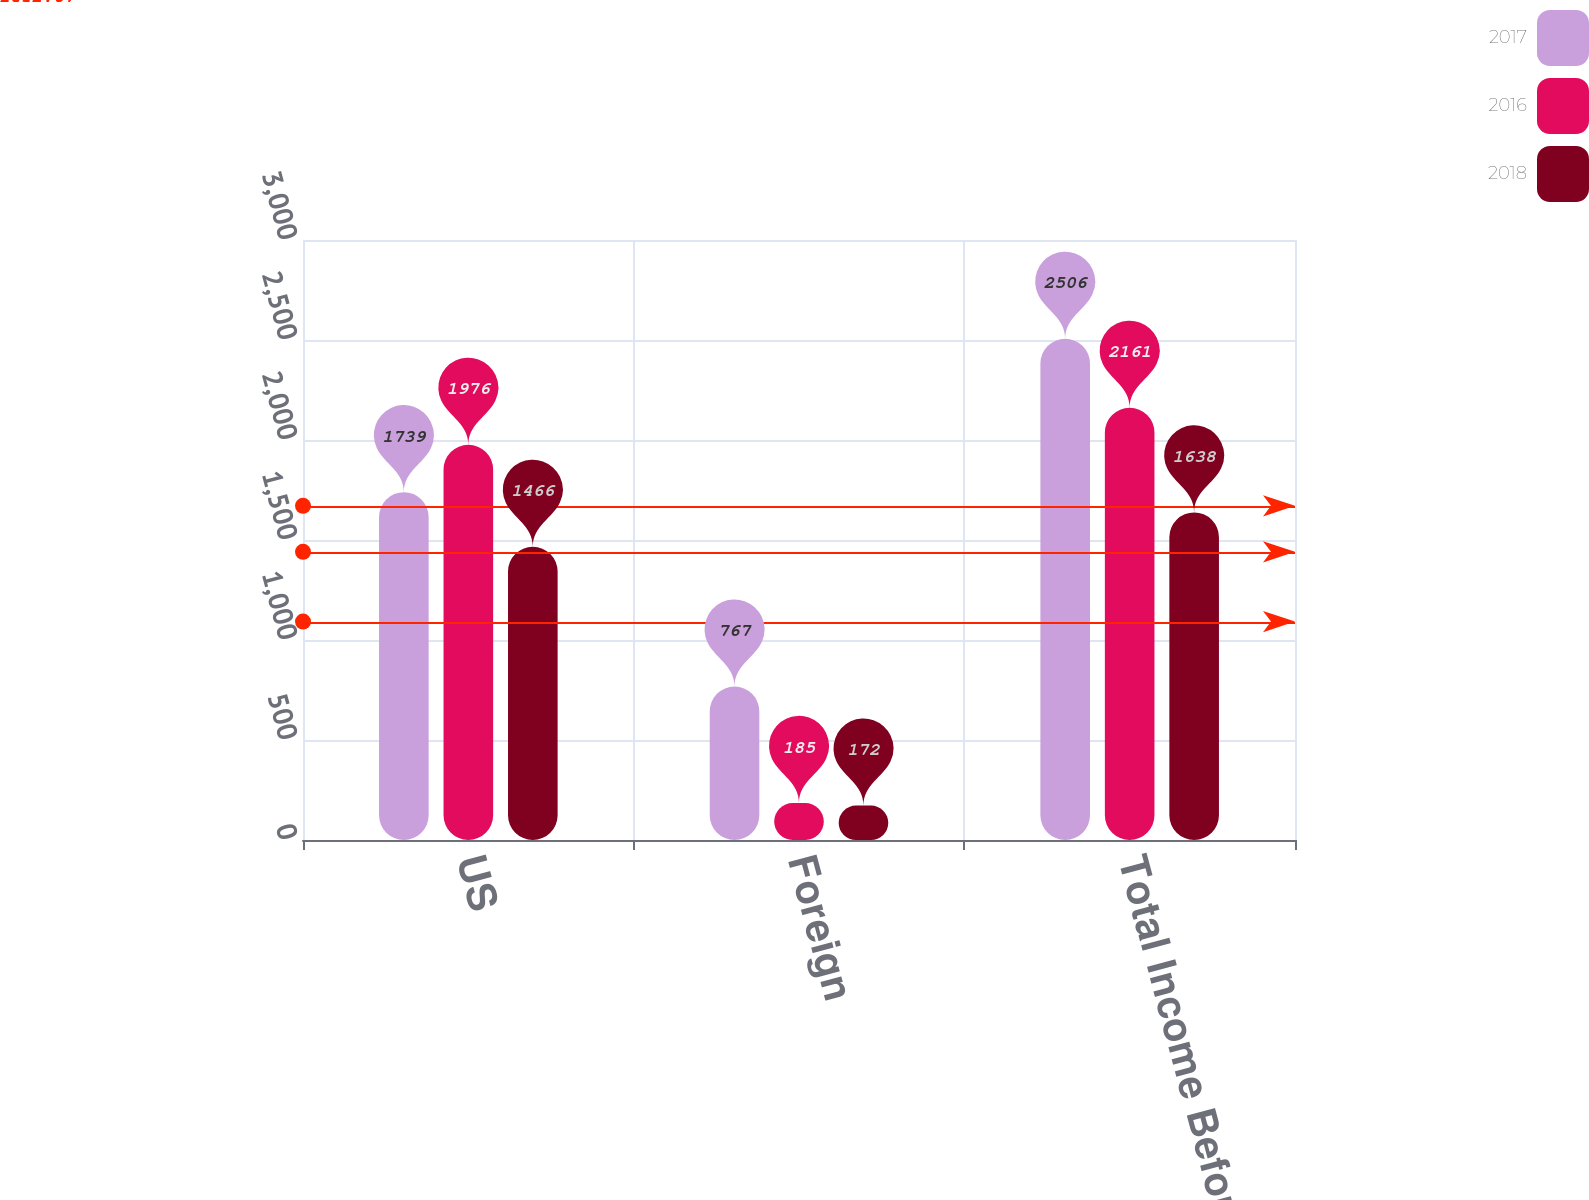Convert chart. <chart><loc_0><loc_0><loc_500><loc_500><stacked_bar_chart><ecel><fcel>US<fcel>Foreign<fcel>Total Income Before Income<nl><fcel>2017<fcel>1739<fcel>767<fcel>2506<nl><fcel>2016<fcel>1976<fcel>185<fcel>2161<nl><fcel>2018<fcel>1466<fcel>172<fcel>1638<nl></chart> 